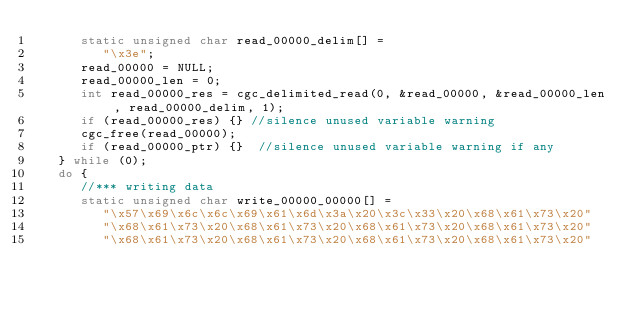<code> <loc_0><loc_0><loc_500><loc_500><_C_>      static unsigned char read_00000_delim[] = 
         "\x3e";
      read_00000 = NULL;
      read_00000_len = 0;
      int read_00000_res = cgc_delimited_read(0, &read_00000, &read_00000_len, read_00000_delim, 1);
      if (read_00000_res) {} //silence unused variable warning
      cgc_free(read_00000);
      if (read_00000_ptr) {}  //silence unused variable warning if any
   } while (0);
   do {
      //*** writing data
      static unsigned char write_00000_00000[] = 
         "\x57\x69\x6c\x6c\x69\x61\x6d\x3a\x20\x3c\x33\x20\x68\x61\x73\x20"
         "\x68\x61\x73\x20\x68\x61\x73\x20\x68\x61\x73\x20\x68\x61\x73\x20"
         "\x68\x61\x73\x20\x68\x61\x73\x20\x68\x61\x73\x20\x68\x61\x73\x20"</code> 